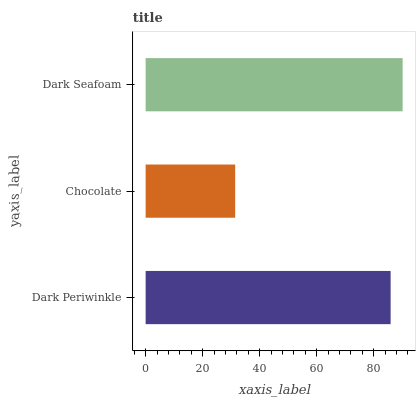Is Chocolate the minimum?
Answer yes or no. Yes. Is Dark Seafoam the maximum?
Answer yes or no. Yes. Is Dark Seafoam the minimum?
Answer yes or no. No. Is Chocolate the maximum?
Answer yes or no. No. Is Dark Seafoam greater than Chocolate?
Answer yes or no. Yes. Is Chocolate less than Dark Seafoam?
Answer yes or no. Yes. Is Chocolate greater than Dark Seafoam?
Answer yes or no. No. Is Dark Seafoam less than Chocolate?
Answer yes or no. No. Is Dark Periwinkle the high median?
Answer yes or no. Yes. Is Dark Periwinkle the low median?
Answer yes or no. Yes. Is Dark Seafoam the high median?
Answer yes or no. No. Is Chocolate the low median?
Answer yes or no. No. 